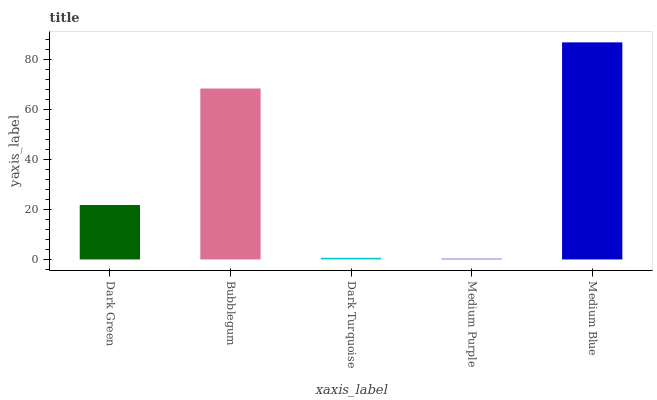Is Medium Purple the minimum?
Answer yes or no. Yes. Is Medium Blue the maximum?
Answer yes or no. Yes. Is Bubblegum the minimum?
Answer yes or no. No. Is Bubblegum the maximum?
Answer yes or no. No. Is Bubblegum greater than Dark Green?
Answer yes or no. Yes. Is Dark Green less than Bubblegum?
Answer yes or no. Yes. Is Dark Green greater than Bubblegum?
Answer yes or no. No. Is Bubblegum less than Dark Green?
Answer yes or no. No. Is Dark Green the high median?
Answer yes or no. Yes. Is Dark Green the low median?
Answer yes or no. Yes. Is Bubblegum the high median?
Answer yes or no. No. Is Medium Purple the low median?
Answer yes or no. No. 